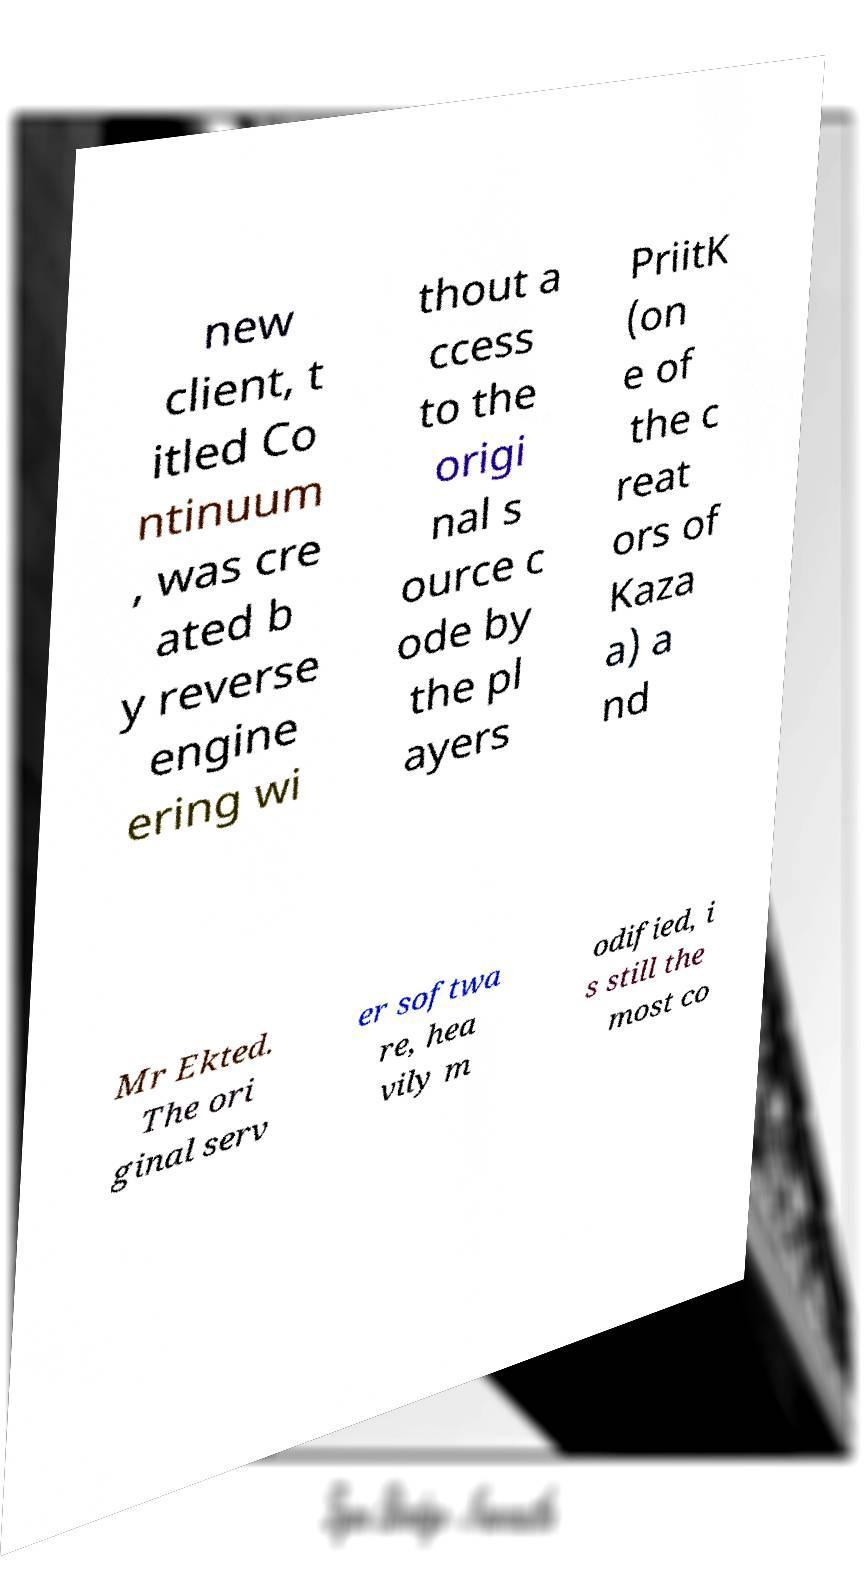Can you read and provide the text displayed in the image?This photo seems to have some interesting text. Can you extract and type it out for me? new client, t itled Co ntinuum , was cre ated b y reverse engine ering wi thout a ccess to the origi nal s ource c ode by the pl ayers PriitK (on e of the c reat ors of Kaza a) a nd Mr Ekted. The ori ginal serv er softwa re, hea vily m odified, i s still the most co 